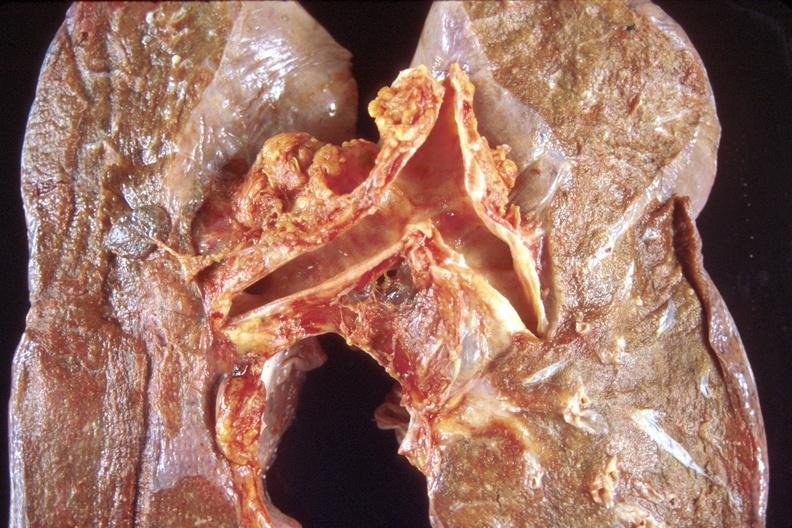where is this?
Answer the question using a single word or phrase. Lung 